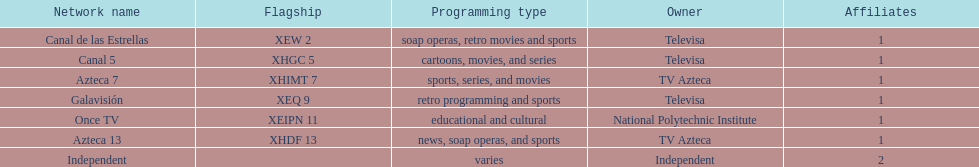What is the only network owned by national polytechnic institute? Once TV. 